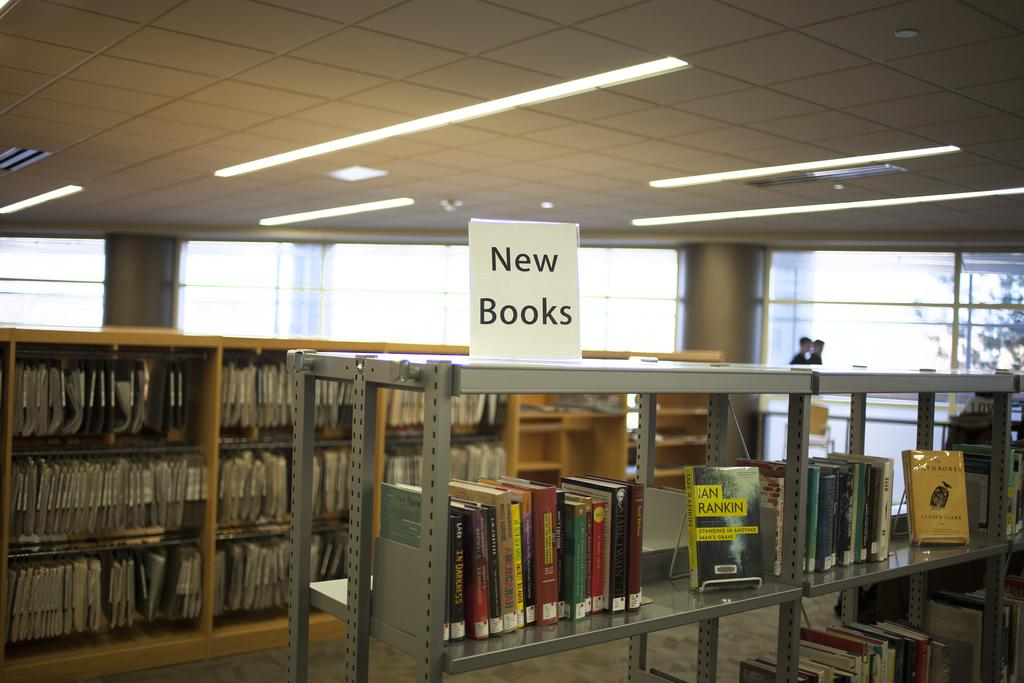<image>
Present a compact description of the photo's key features. a building full of shelves with one that is labeled 'new books' 